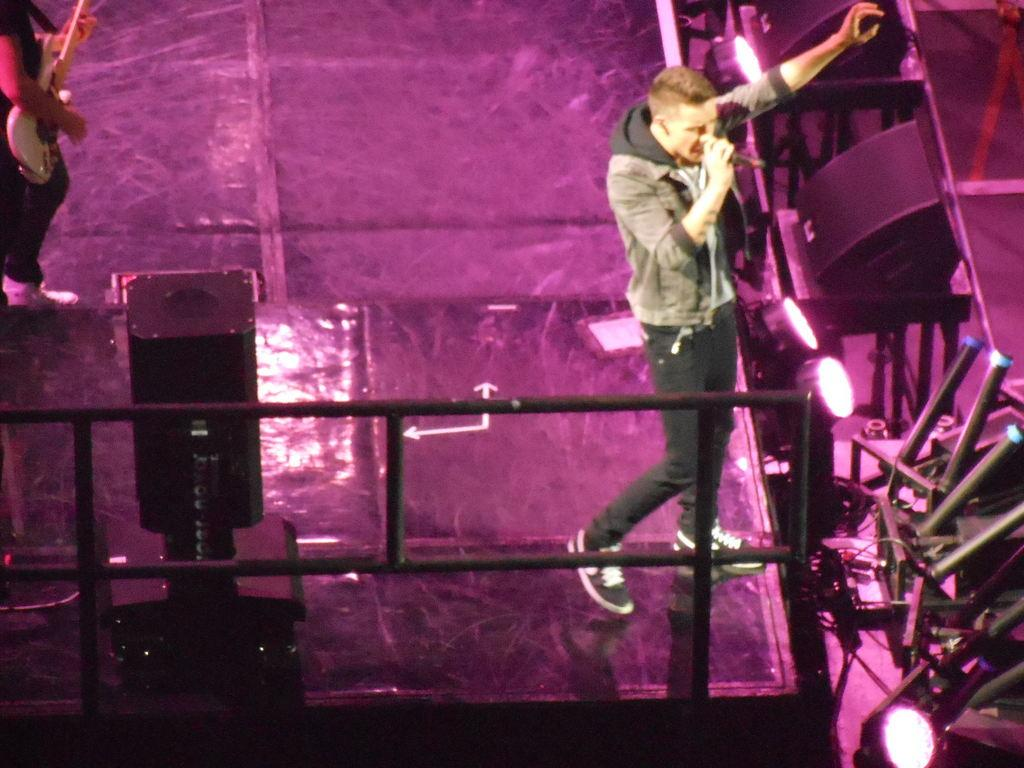How many people are playing a guitar in the image? There are two people playing a guitar in the image. Where are the guitar players located in the image? One person is standing on the right side of the image, and the other is standing on the top left of the image. What are the guitar players doing in the image? The guitar players are playing their guitars. What type of zephyr can be seen blowing through the image? There is no zephyr present in the image; it is a still image of two guitar players. What causes the burst of sound when the guitar players strum their guitars? The burst of sound is caused by the guitar players strumming their guitars, not by any external factors mentioned in the image. 